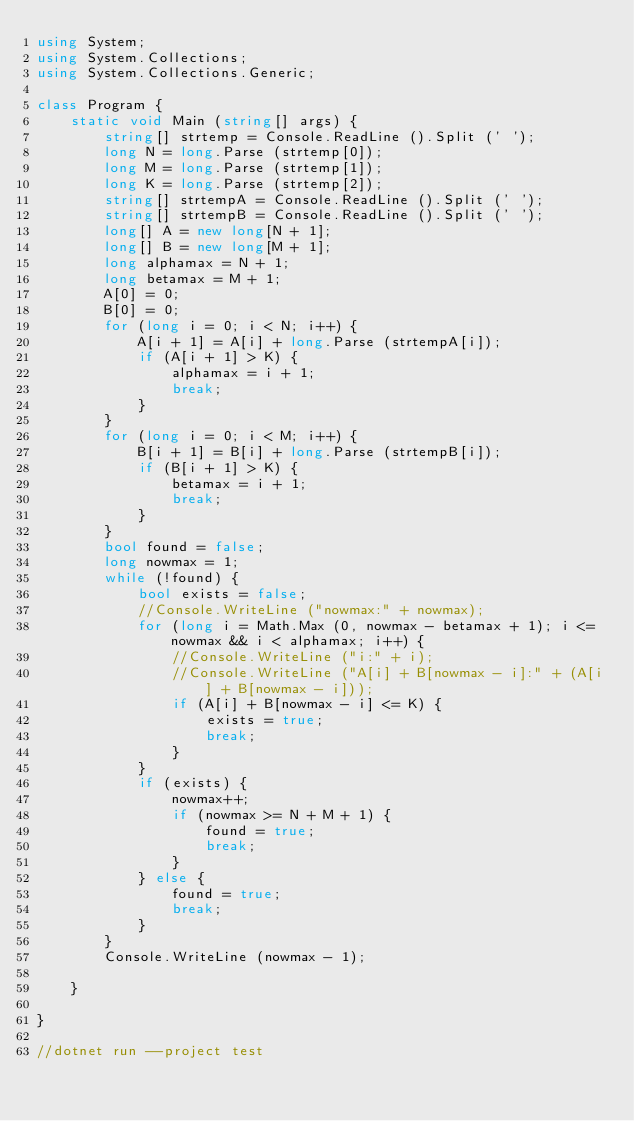Convert code to text. <code><loc_0><loc_0><loc_500><loc_500><_C#_>using System;
using System.Collections;
using System.Collections.Generic;

class Program {
    static void Main (string[] args) {
        string[] strtemp = Console.ReadLine ().Split (' ');
        long N = long.Parse (strtemp[0]);
        long M = long.Parse (strtemp[1]);
        long K = long.Parse (strtemp[2]);
        string[] strtempA = Console.ReadLine ().Split (' ');
        string[] strtempB = Console.ReadLine ().Split (' ');
        long[] A = new long[N + 1];
        long[] B = new long[M + 1];
        long alphamax = N + 1;
        long betamax = M + 1;
        A[0] = 0;
        B[0] = 0;
        for (long i = 0; i < N; i++) {
            A[i + 1] = A[i] + long.Parse (strtempA[i]);
            if (A[i + 1] > K) {
                alphamax = i + 1;
                break;
            }
        }
        for (long i = 0; i < M; i++) {
            B[i + 1] = B[i] + long.Parse (strtempB[i]);
            if (B[i + 1] > K) {
                betamax = i + 1;
                break;
            }
        }
        bool found = false;
        long nowmax = 1;
        while (!found) {
            bool exists = false;
            //Console.WriteLine ("nowmax:" + nowmax);
            for (long i = Math.Max (0, nowmax - betamax + 1); i <= nowmax && i < alphamax; i++) {
                //Console.WriteLine ("i:" + i);
                //Console.WriteLine ("A[i] + B[nowmax - i]:" + (A[i] + B[nowmax - i]));
                if (A[i] + B[nowmax - i] <= K) {
                    exists = true;
                    break;
                }
            }
            if (exists) {
                nowmax++;
                if (nowmax >= N + M + 1) {
                    found = true;
                    break;
                }
            } else {
                found = true;
                break;
            }
        }
        Console.WriteLine (nowmax - 1);

    }

}

//dotnet run --project test</code> 